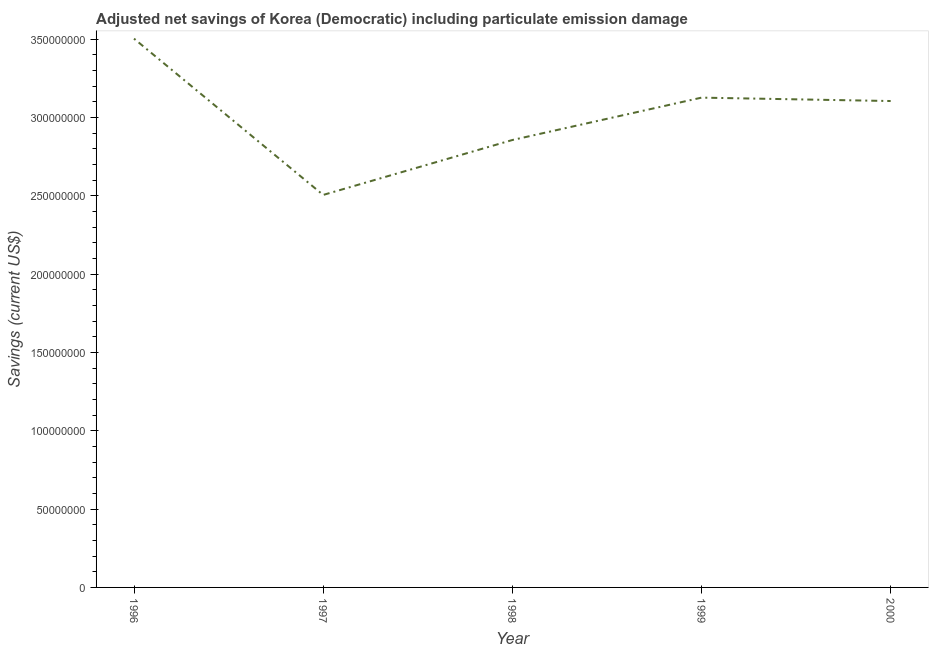What is the adjusted net savings in 1998?
Offer a very short reply. 2.86e+08. Across all years, what is the maximum adjusted net savings?
Your answer should be compact. 3.50e+08. Across all years, what is the minimum adjusted net savings?
Ensure brevity in your answer.  2.51e+08. In which year was the adjusted net savings minimum?
Keep it short and to the point. 1997. What is the sum of the adjusted net savings?
Offer a very short reply. 1.51e+09. What is the difference between the adjusted net savings in 1997 and 2000?
Provide a succinct answer. -6.00e+07. What is the average adjusted net savings per year?
Offer a terse response. 3.02e+08. What is the median adjusted net savings?
Make the answer very short. 3.11e+08. Do a majority of the years between 1997 and 2000 (inclusive) have adjusted net savings greater than 50000000 US$?
Your answer should be very brief. Yes. What is the ratio of the adjusted net savings in 1997 to that in 1999?
Make the answer very short. 0.8. What is the difference between the highest and the second highest adjusted net savings?
Offer a terse response. 3.77e+07. Is the sum of the adjusted net savings in 1997 and 1999 greater than the maximum adjusted net savings across all years?
Your answer should be very brief. Yes. What is the difference between the highest and the lowest adjusted net savings?
Your answer should be compact. 9.98e+07. Does the adjusted net savings monotonically increase over the years?
Ensure brevity in your answer.  No. How many years are there in the graph?
Provide a succinct answer. 5. Does the graph contain any zero values?
Keep it short and to the point. No. Does the graph contain grids?
Provide a short and direct response. No. What is the title of the graph?
Your response must be concise. Adjusted net savings of Korea (Democratic) including particulate emission damage. What is the label or title of the Y-axis?
Give a very brief answer. Savings (current US$). What is the Savings (current US$) of 1996?
Give a very brief answer. 3.50e+08. What is the Savings (current US$) in 1997?
Ensure brevity in your answer.  2.51e+08. What is the Savings (current US$) of 1998?
Provide a succinct answer. 2.86e+08. What is the Savings (current US$) of 1999?
Keep it short and to the point. 3.13e+08. What is the Savings (current US$) in 2000?
Keep it short and to the point. 3.11e+08. What is the difference between the Savings (current US$) in 1996 and 1997?
Offer a very short reply. 9.98e+07. What is the difference between the Savings (current US$) in 1996 and 1998?
Provide a short and direct response. 6.47e+07. What is the difference between the Savings (current US$) in 1996 and 1999?
Make the answer very short. 3.77e+07. What is the difference between the Savings (current US$) in 1996 and 2000?
Provide a succinct answer. 3.98e+07. What is the difference between the Savings (current US$) in 1997 and 1998?
Give a very brief answer. -3.51e+07. What is the difference between the Savings (current US$) in 1997 and 1999?
Provide a succinct answer. -6.21e+07. What is the difference between the Savings (current US$) in 1997 and 2000?
Offer a terse response. -6.00e+07. What is the difference between the Savings (current US$) in 1998 and 1999?
Ensure brevity in your answer.  -2.71e+07. What is the difference between the Savings (current US$) in 1998 and 2000?
Provide a succinct answer. -2.49e+07. What is the difference between the Savings (current US$) in 1999 and 2000?
Your answer should be very brief. 2.17e+06. What is the ratio of the Savings (current US$) in 1996 to that in 1997?
Offer a very short reply. 1.4. What is the ratio of the Savings (current US$) in 1996 to that in 1998?
Offer a terse response. 1.23. What is the ratio of the Savings (current US$) in 1996 to that in 1999?
Give a very brief answer. 1.12. What is the ratio of the Savings (current US$) in 1996 to that in 2000?
Your answer should be very brief. 1.13. What is the ratio of the Savings (current US$) in 1997 to that in 1998?
Your answer should be very brief. 0.88. What is the ratio of the Savings (current US$) in 1997 to that in 1999?
Provide a succinct answer. 0.8. What is the ratio of the Savings (current US$) in 1997 to that in 2000?
Provide a short and direct response. 0.81. What is the ratio of the Savings (current US$) in 1998 to that in 2000?
Your answer should be very brief. 0.92. 